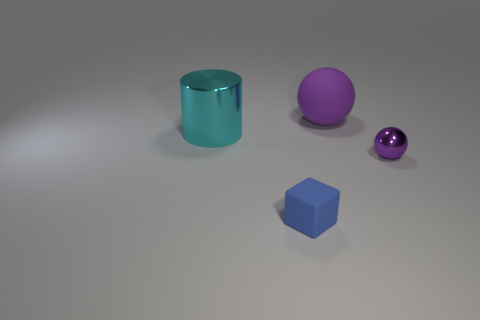Add 4 large metallic things. How many objects exist? 8 Subtract all big blue balls. Subtract all small metallic balls. How many objects are left? 3 Add 2 shiny things. How many shiny things are left? 4 Add 3 large cyan cylinders. How many large cyan cylinders exist? 4 Subtract 1 blue blocks. How many objects are left? 3 